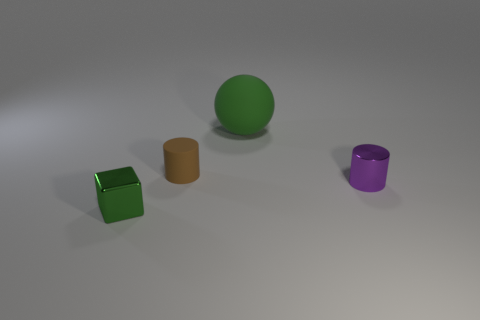How many large green rubber spheres are behind the tiny metal cube?
Keep it short and to the point. 1. How big is the purple object?
Provide a short and direct response. Small. What color is the matte thing that is the same size as the purple metallic object?
Offer a very short reply. Brown. Are there any rubber objects of the same color as the rubber ball?
Your response must be concise. No. What is the material of the purple cylinder?
Make the answer very short. Metal. What number of green balls are there?
Your answer should be very brief. 1. There is a object in front of the small purple thing; is it the same color as the object that is behind the small brown rubber object?
Your answer should be very brief. Yes. There is a ball that is the same color as the cube; what size is it?
Your answer should be very brief. Large. What number of other things are the same size as the green metallic cube?
Provide a succinct answer. 2. There is a shiny thing that is on the right side of the rubber ball; what color is it?
Give a very brief answer. Purple. 